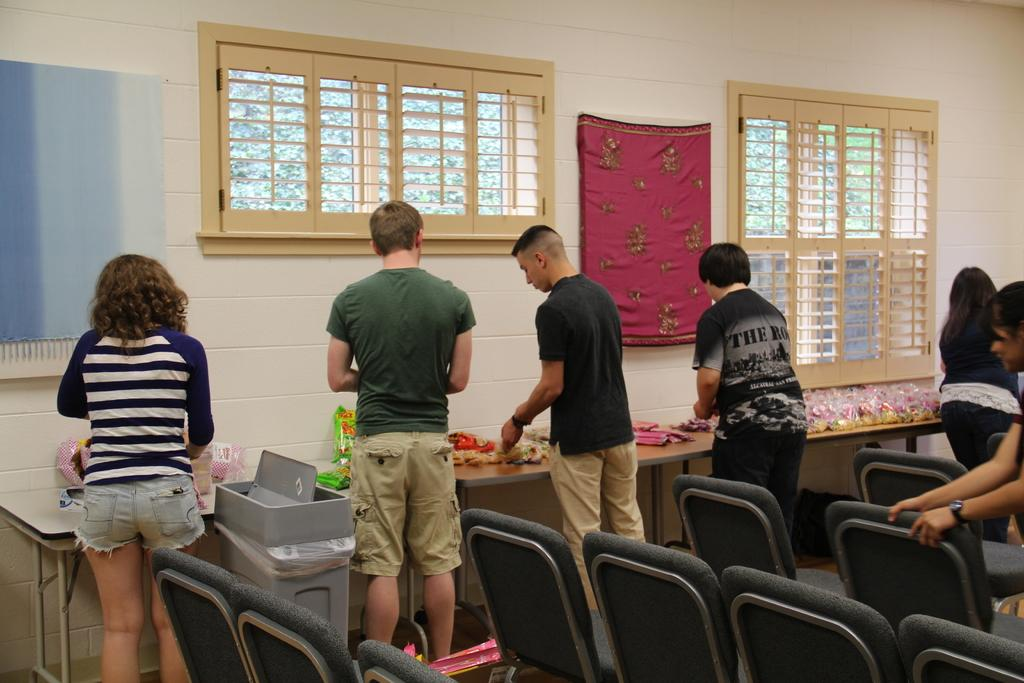What can be seen in the image? There are people standing in the image. What is in front of the people? There is a table in front of the people. What can be seen in the background of the image? There is a window visible in the background of the image. What flavor of prison is depicted in the image? There is no prison present in the image, and therefore no flavor can be associated with it. 